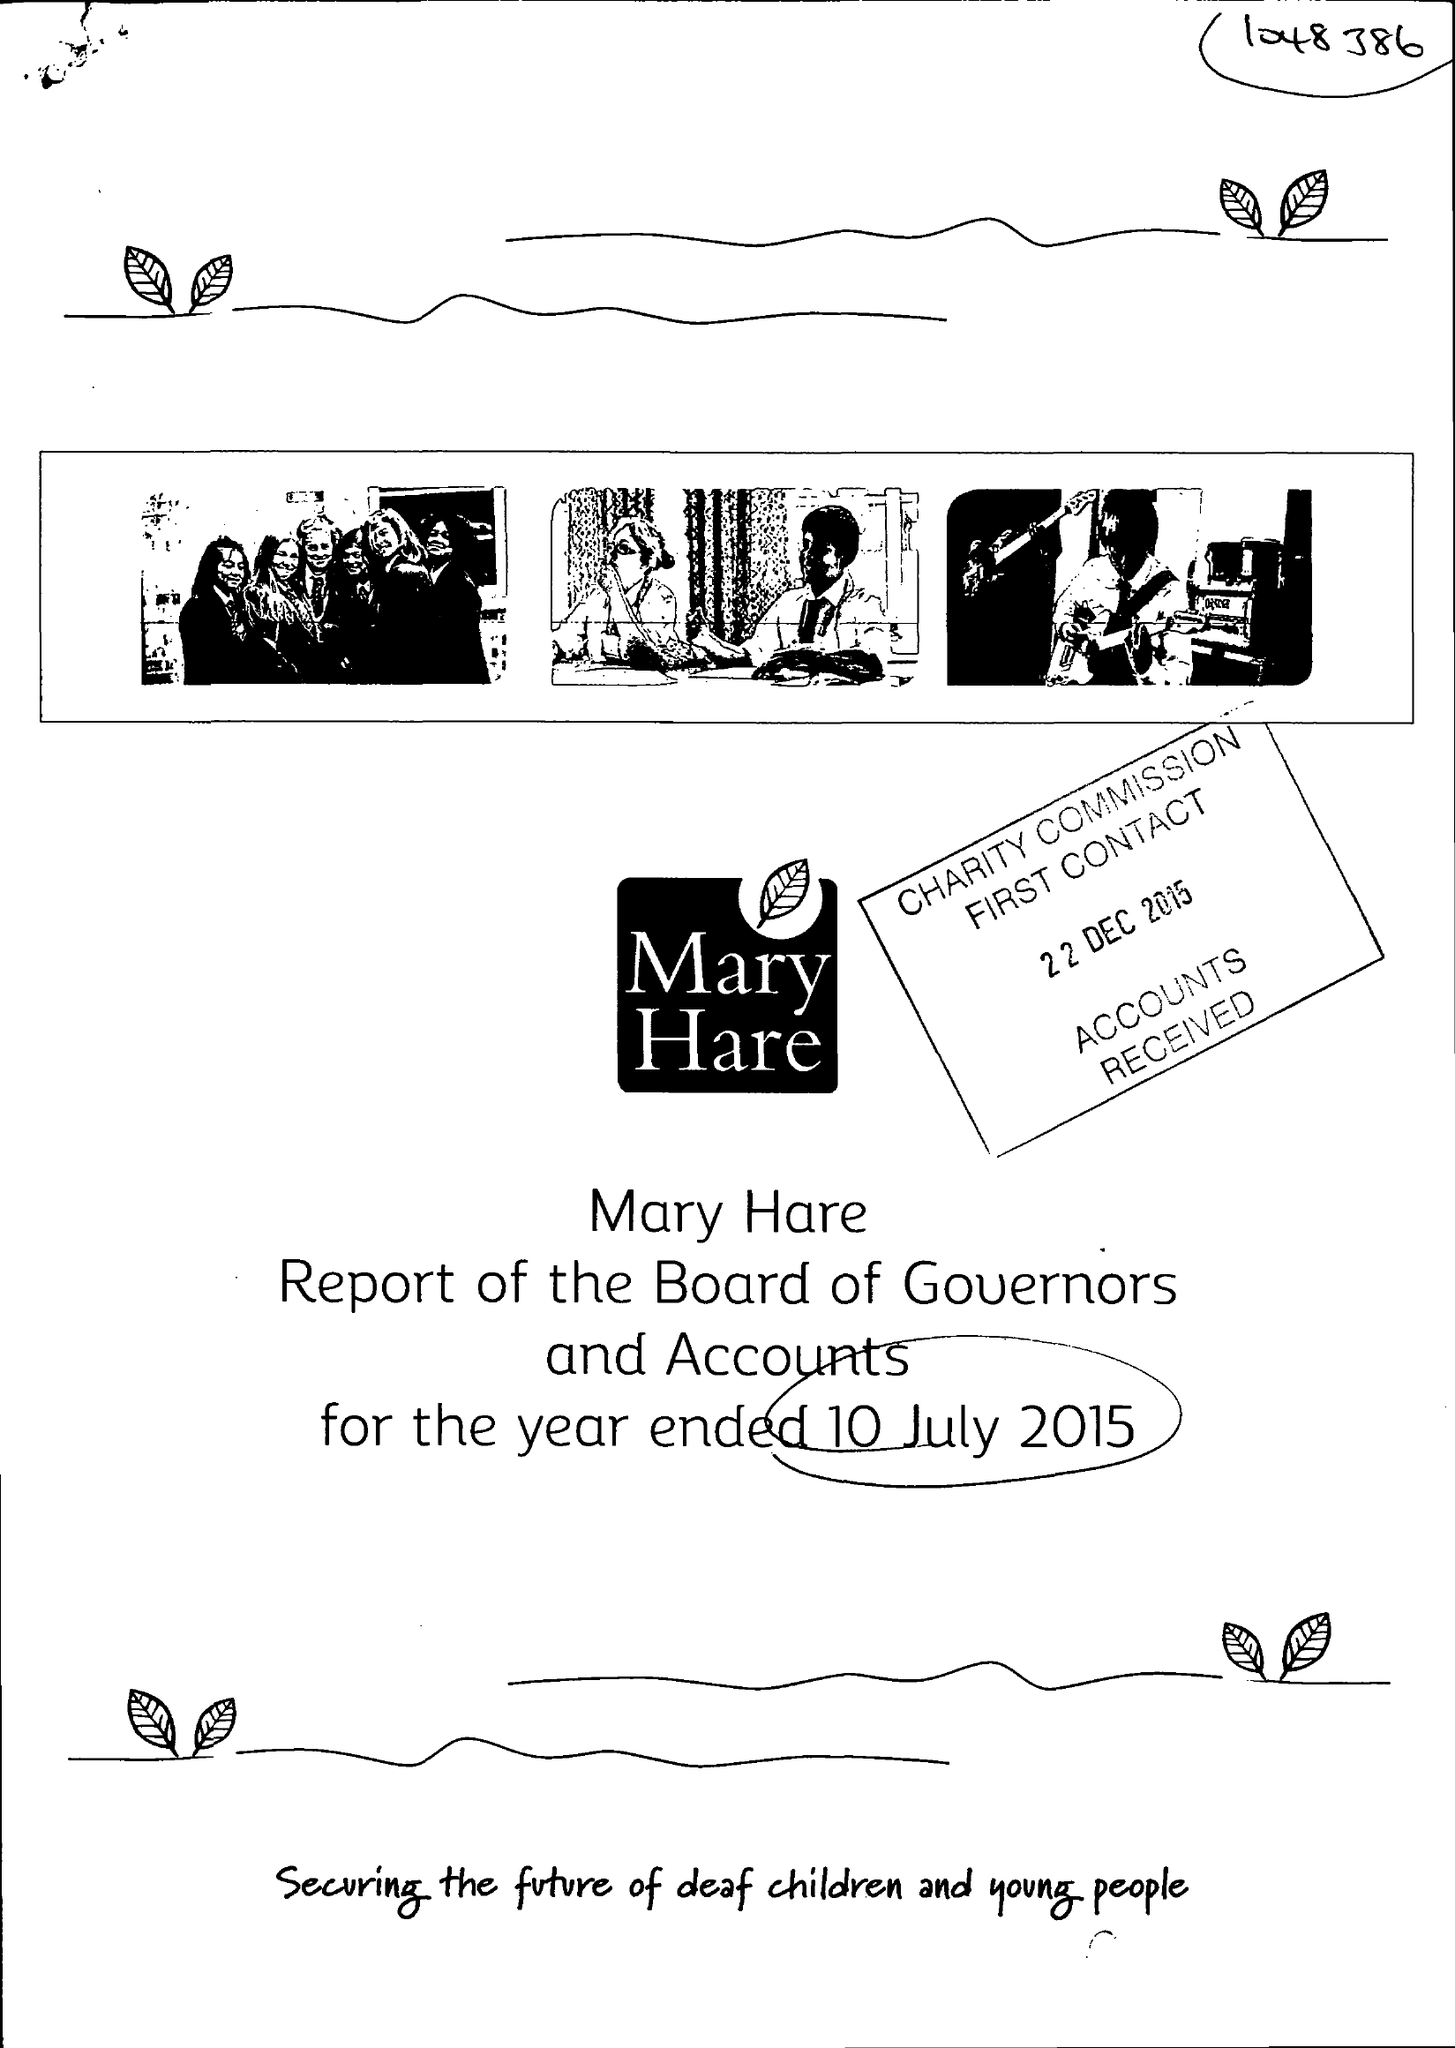What is the value for the address__postcode?
Answer the question using a single word or phrase. RG14 3BQ 